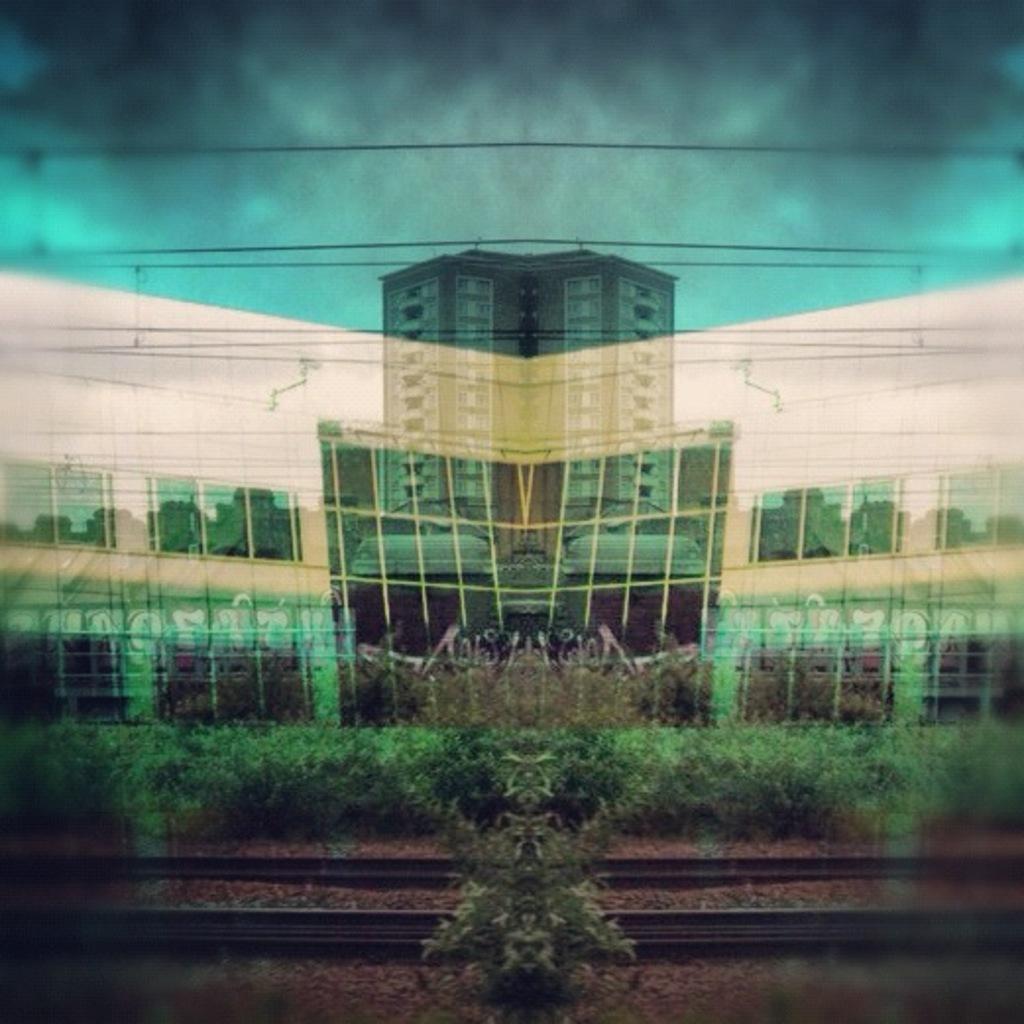Could you give a brief overview of what you see in this image? In this picture I can see building, few plants and couple of railway tracks and I can see sky. 